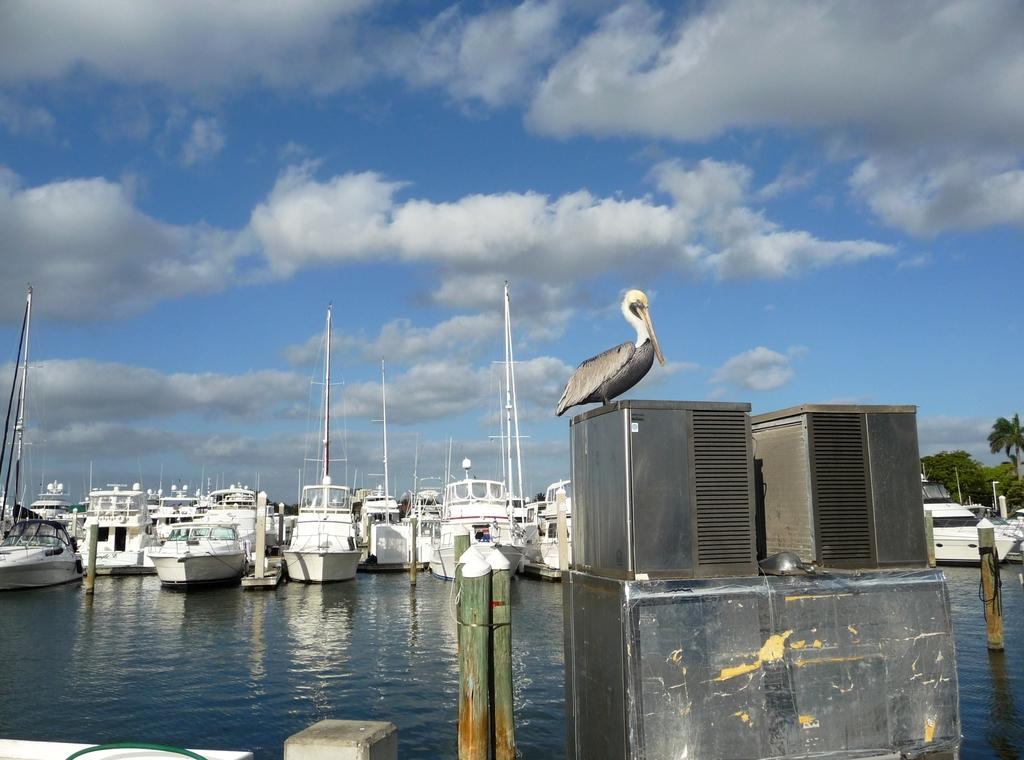What is the bird in the image sitting on? The bird is sitting on a metal rod in the image. What type of structure can be seen in the image? There is a fence in the image. What is visible in the water in the image? There are boats in the water in the image. What is visible at the top of the image? The sky is visible at the top of the image. Can you describe the possible location of the image? The image may have been taken near the ocean. What type of lunch is the dog eating in the image? There is no dog or lunch present in the image. 